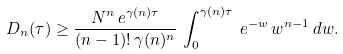<formula> <loc_0><loc_0><loc_500><loc_500>D _ { n } ( \tau ) \geq \frac { N ^ { n } \, e ^ { \gamma ( n ) \tau } } { ( n - 1 ) ! \, \gamma ( n ) ^ { n } } \, \int _ { 0 } ^ { \gamma ( n ) \tau } \, e ^ { - w } \, w ^ { n - 1 } \, d w .</formula> 